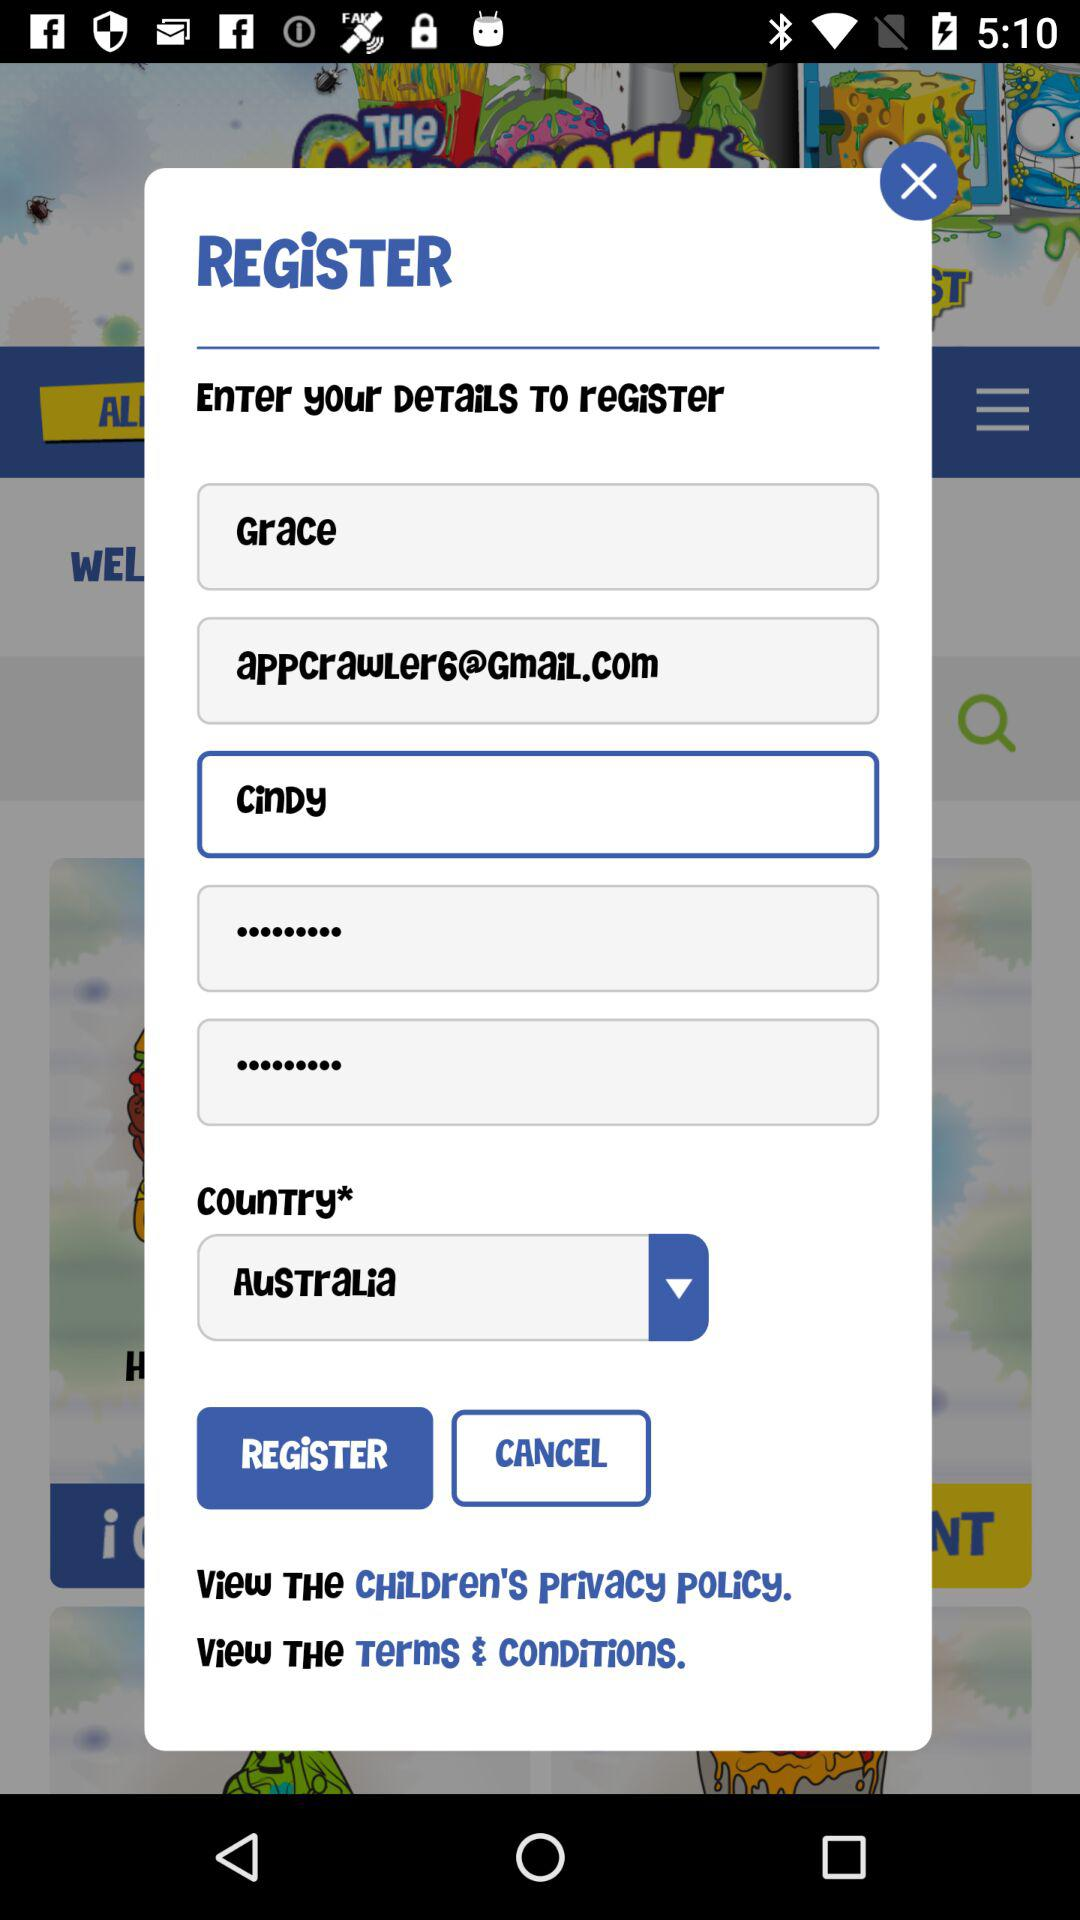What window is currently open? The currently open window is "REGiSTER". 